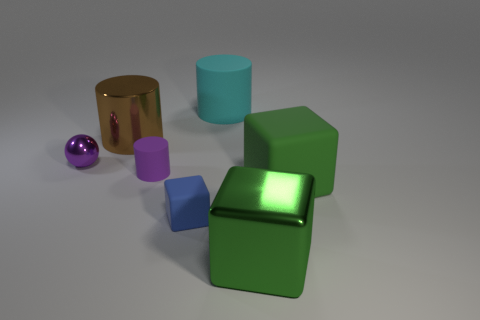Subtract all tiny rubber cylinders. How many cylinders are left? 2 Add 1 metallic cubes. How many objects exist? 8 Subtract all blue cubes. How many cubes are left? 2 Subtract all purple cylinders. How many green cubes are left? 2 Subtract all balls. How many objects are left? 6 Subtract 1 cylinders. How many cylinders are left? 2 Subtract all big rubber things. Subtract all large red metal things. How many objects are left? 5 Add 2 matte objects. How many matte objects are left? 6 Add 4 yellow balls. How many yellow balls exist? 4 Subtract 0 yellow cylinders. How many objects are left? 7 